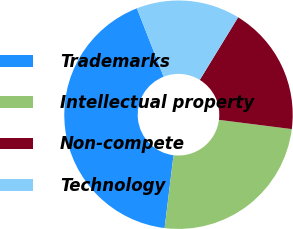<chart> <loc_0><loc_0><loc_500><loc_500><pie_chart><fcel>Trademarks<fcel>Intellectual property<fcel>Non-compete<fcel>Technology<nl><fcel>42.14%<fcel>24.93%<fcel>18.27%<fcel>14.67%<nl></chart> 